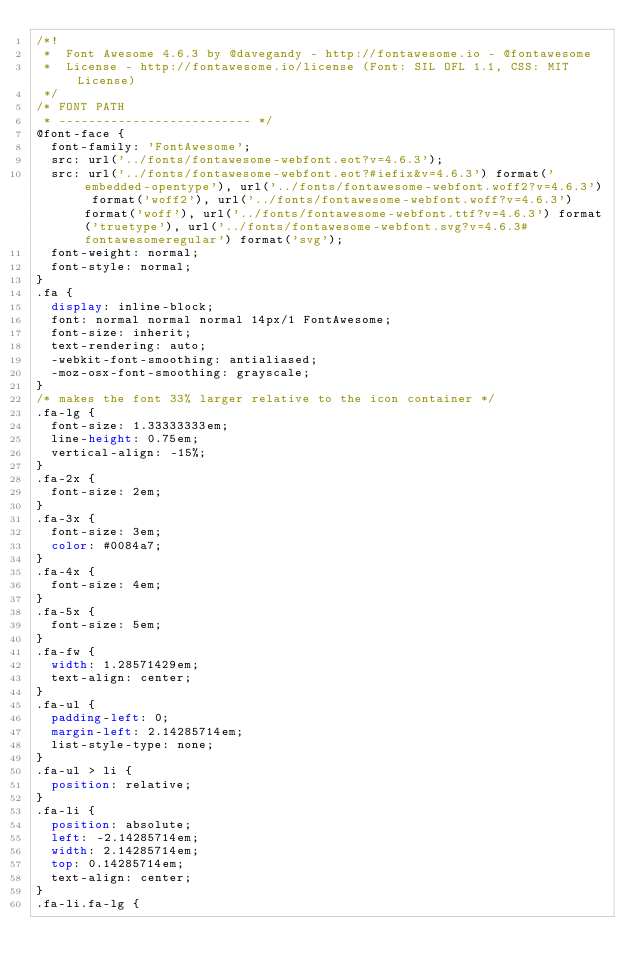<code> <loc_0><loc_0><loc_500><loc_500><_CSS_>/*!
 *  Font Awesome 4.6.3 by @davegandy - http://fontawesome.io - @fontawesome
 *  License - http://fontawesome.io/license (Font: SIL OFL 1.1, CSS: MIT License)
 */
/* FONT PATH
 * -------------------------- */
@font-face {
  font-family: 'FontAwesome';
  src: url('../fonts/fontawesome-webfont.eot?v=4.6.3');
  src: url('../fonts/fontawesome-webfont.eot?#iefix&v=4.6.3') format('embedded-opentype'), url('../fonts/fontawesome-webfont.woff2?v=4.6.3') format('woff2'), url('../fonts/fontawesome-webfont.woff?v=4.6.3') format('woff'), url('../fonts/fontawesome-webfont.ttf?v=4.6.3') format('truetype'), url('../fonts/fontawesome-webfont.svg?v=4.6.3#fontawesomeregular') format('svg');
  font-weight: normal;
  font-style: normal;
}
.fa {
  display: inline-block;
  font: normal normal normal 14px/1 FontAwesome;
  font-size: inherit;
  text-rendering: auto;
  -webkit-font-smoothing: antialiased;
  -moz-osx-font-smoothing: grayscale;
}
/* makes the font 33% larger relative to the icon container */
.fa-lg {
  font-size: 1.33333333em;
  line-height: 0.75em;
  vertical-align: -15%;
}
.fa-2x {
  font-size: 2em;
}
.fa-3x {
  font-size: 3em;
  color: #0084a7;
}
.fa-4x {
  font-size: 4em;
}
.fa-5x {
  font-size: 5em;
}
.fa-fw {
  width: 1.28571429em;
  text-align: center;
}
.fa-ul {
  padding-left: 0;
  margin-left: 2.14285714em;
  list-style-type: none;
}
.fa-ul > li {
  position: relative;
}
.fa-li {
  position: absolute;
  left: -2.14285714em;
  width: 2.14285714em;
  top: 0.14285714em;
  text-align: center;
}
.fa-li.fa-lg {</code> 